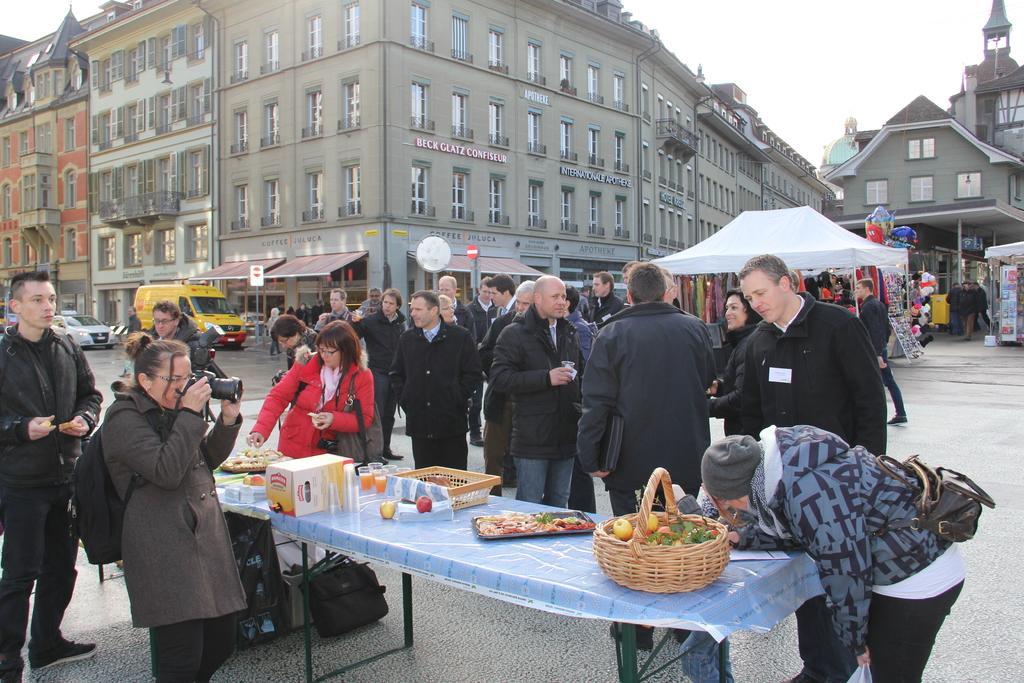Could you give a brief overview of what you see in this image? At the top we can see sky. These are buildings. We can see all the persons standing and talking near to the table and on the table we can see a basket of fruits, a plate of cooking items, juice glasses. under the table we can see a bag. We can see one woman at the left side of the picture. She is holding a camera in her hand and taking a snap. We can see vehicles on the road. 